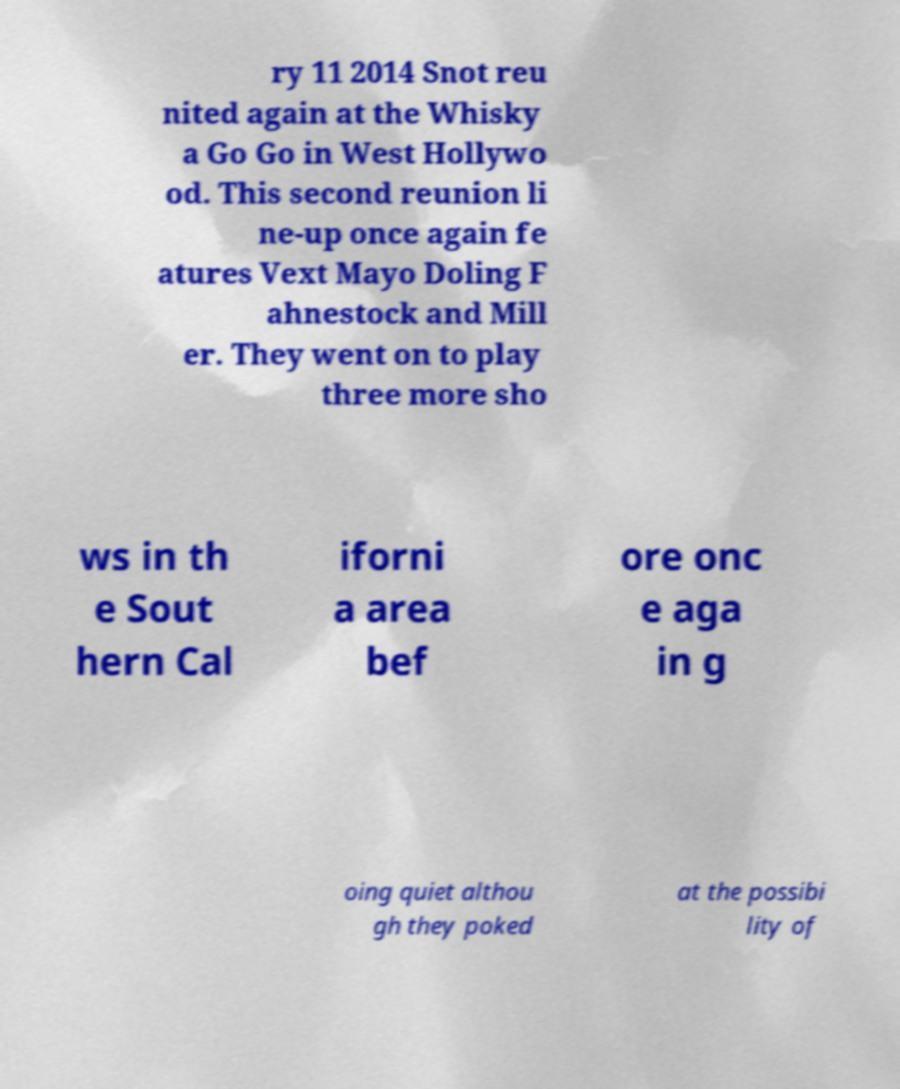Please identify and transcribe the text found in this image. ry 11 2014 Snot reu nited again at the Whisky a Go Go in West Hollywo od. This second reunion li ne-up once again fe atures Vext Mayo Doling F ahnestock and Mill er. They went on to play three more sho ws in th e Sout hern Cal iforni a area bef ore onc e aga in g oing quiet althou gh they poked at the possibi lity of 